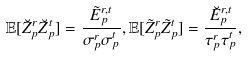Convert formula to latex. <formula><loc_0><loc_0><loc_500><loc_500>\mathbb { E } [ \breve { Z } _ { p } ^ { r } \breve { Z } _ { p } ^ { t } ] = \frac { \tilde { E } _ { p } ^ { r , t } } { \sigma _ { p } ^ { r } \sigma _ { p } ^ { t } } , \mathbb { E } [ \tilde { Z } _ { p } ^ { r } \tilde { Z } _ { p } ^ { t } ] = \frac { \breve { E } _ { p } ^ { r , t } } { \tau _ { p } ^ { r } \tau _ { p } ^ { t } } ,</formula> 